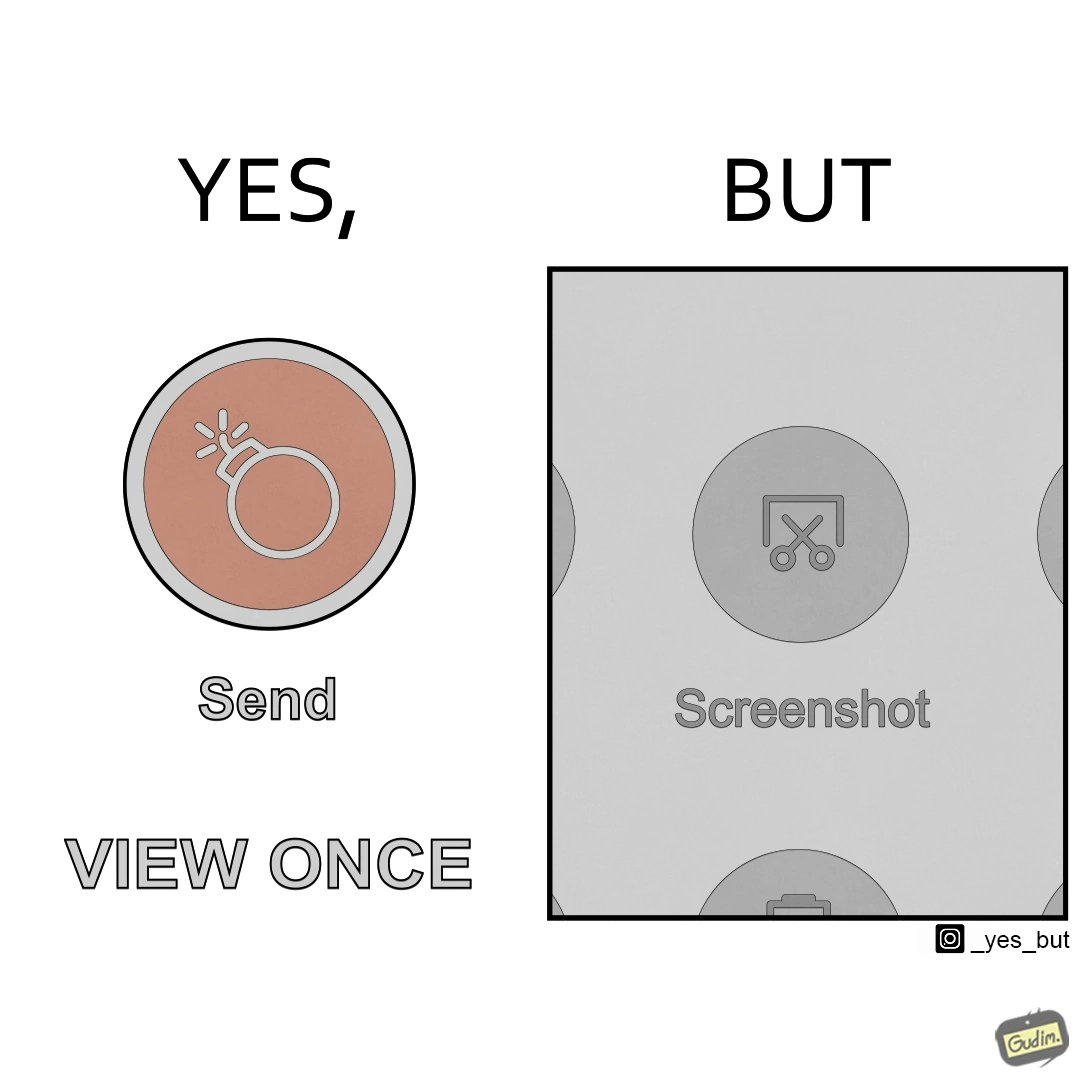Describe the contrast between the left and right parts of this image. In the left part of the image: It is a send button with a 'view only once' option activated In the right part of the image: It is a screenshot button 